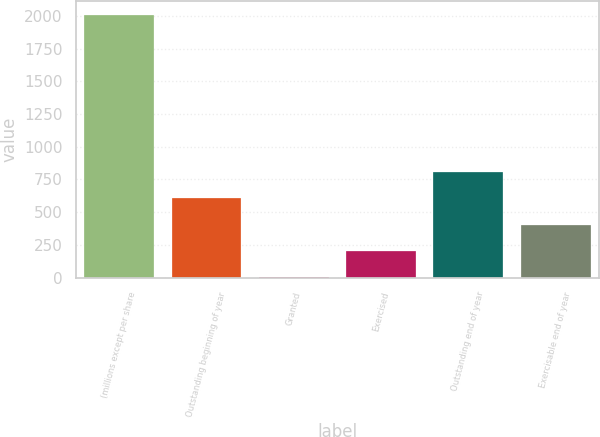Convert chart. <chart><loc_0><loc_0><loc_500><loc_500><bar_chart><fcel>(millions except per share<fcel>Outstanding beginning of year<fcel>Granted<fcel>Exercised<fcel>Outstanding end of year<fcel>Exercisable end of year<nl><fcel>2010<fcel>605.8<fcel>4<fcel>204.6<fcel>806.4<fcel>405.2<nl></chart> 